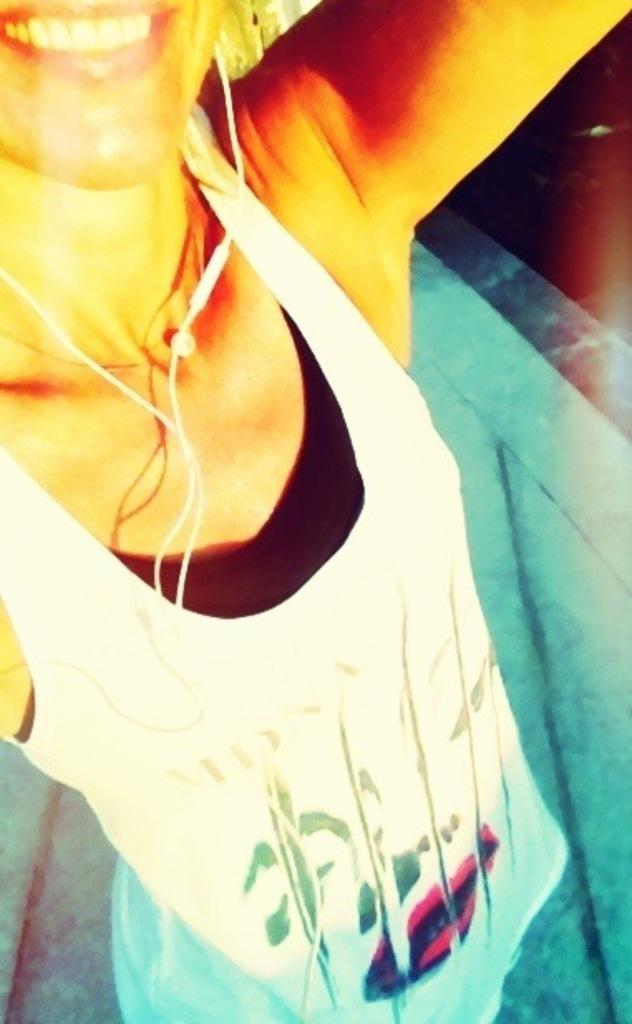Who is the main subject in the picture? There is a girl in the picture. What is the girl wearing? The girl is wearing a white top. What can be seen in the girl's ears? The girl has headphones in her ears. What is the girl's facial expression? The girl is smiling. What is the girl doing in the picture? The girl is giving a pose into the camera. What type of pancake is the girl eating in the picture? There is no pancake present in the image; the girl is wearing a white top and has headphones in her ears. 